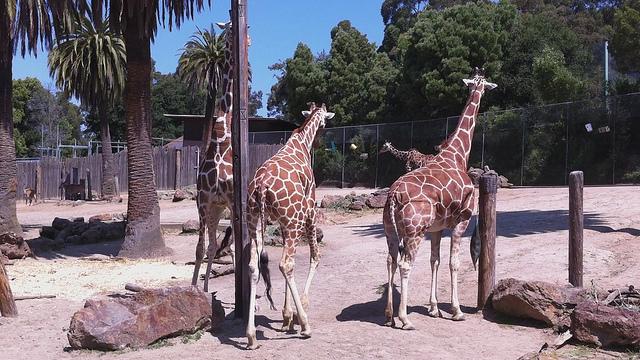What kind of trees are shown?
Write a very short answer. Palm. Are the giraffes in the ZOO?
Write a very short answer. Yes. How many giraffes?
Short answer required. 4. 